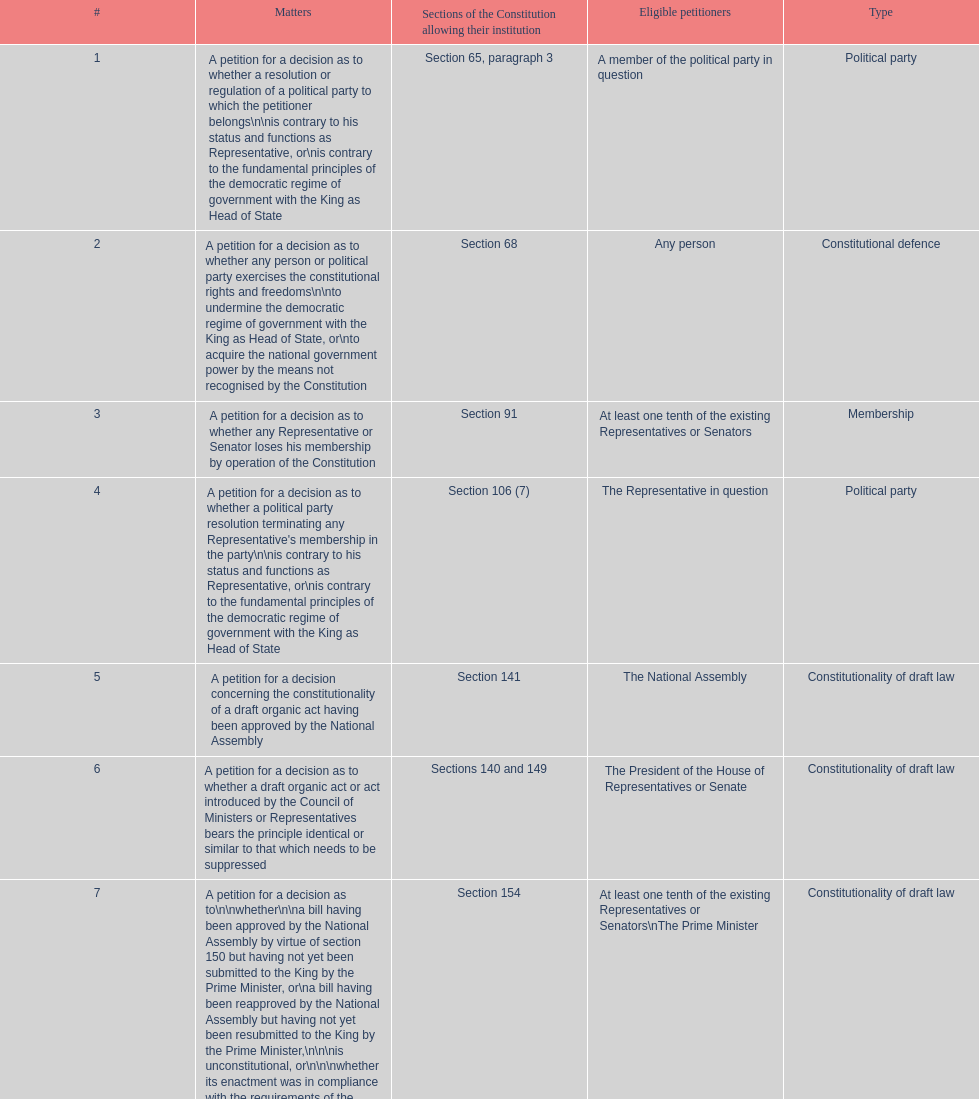Could you help me parse every detail presented in this table? {'header': ['#', 'Matters', 'Sections of the Constitution allowing their institution', 'Eligible petitioners', 'Type'], 'rows': [['1', 'A petition for a decision as to whether a resolution or regulation of a political party to which the petitioner belongs\\n\\nis contrary to his status and functions as Representative, or\\nis contrary to the fundamental principles of the democratic regime of government with the King as Head of State', 'Section 65, paragraph 3', 'A member of the political party in question', 'Political party'], ['2', 'A petition for a decision as to whether any person or political party exercises the constitutional rights and freedoms\\n\\nto undermine the democratic regime of government with the King as Head of State, or\\nto acquire the national government power by the means not recognised by the Constitution', 'Section 68', 'Any person', 'Constitutional defence'], ['3', 'A petition for a decision as to whether any Representative or Senator loses his membership by operation of the Constitution', 'Section 91', 'At least one tenth of the existing Representatives or Senators', 'Membership'], ['4', "A petition for a decision as to whether a political party resolution terminating any Representative's membership in the party\\n\\nis contrary to his status and functions as Representative, or\\nis contrary to the fundamental principles of the democratic regime of government with the King as Head of State", 'Section 106 (7)', 'The Representative in question', 'Political party'], ['5', 'A petition for a decision concerning the constitutionality of a draft organic act having been approved by the National Assembly', 'Section 141', 'The National Assembly', 'Constitutionality of draft law'], ['6', 'A petition for a decision as to whether a draft organic act or act introduced by the Council of Ministers or Representatives bears the principle identical or similar to that which needs to be suppressed', 'Sections 140 and 149', 'The President of the House of Representatives or Senate', 'Constitutionality of draft law'], ['7', 'A petition for a decision as to\\n\\nwhether\\n\\na bill having been approved by the National Assembly by virtue of section 150 but having not yet been submitted to the King by the Prime Minister, or\\na bill having been reapproved by the National Assembly but having not yet been resubmitted to the King by the Prime Minister,\\n\\n\\nis unconstitutional, or\\n\\n\\nwhether its enactment was in compliance with the requirements of the Constitution', 'Section 154', 'At least one tenth of the existing Representatives or Senators\\nThe Prime Minister', 'Constitutionality of draft law'], ['8', 'A petition for a decision as to\\n\\nwhether the draft rules of order of the House of Representatives, the draft rules of order of the Senate, or the draft rules of order of the National Assembly, which have been approved by the House of Representatives, Senate or National Assembly but have not yet been published in the Government Gazette, are unconstitutional, or\\nwhether their enactment was in compliance with the requirements of the Constitution', 'Section 155', 'At least one tenth of the existing Representatives or Senators\\nThe Prime Minister', 'Constitutionality of draft law'], ['9', 'A petition for a decision as to whether any motion, motion amendment or action introduced during the House of Representatives, Senate or committee proceedings for consideration of a draft bill on annual expenditure budget, additional expenditure budget or expenditure budget transfer, would allow a Representative, Senator or committee member to directly or indirectly be involved in the disbursement of such budget', 'Section 168, paragraph 7', 'At least one tenth of the existing Representatives or Senators', 'Others'], ['10', 'A petition for a decision as to whether any Minister individually loses his ministership', 'Section 182', 'At least one tenth of the existing Representatives or Senators\\nThe Election Commission', 'Membership'], ['11', 'A petition for a decision as to whether an emergency decree is enacted against section 184, paragraph 1 or 2, of the Constitution', 'Section 185', 'At least one fifth of the existing Representatives or Senators', 'Constitutionality of law'], ['12', 'A petition for a decision as to whether any "written agreement" to be concluded by the Executive Branch requires prior parliamentary approval because\\n\\nit contains a provision which would bring about a change in the Thai territory or the extraterritorial areas over which Thailand is competent to exercise sovereignty or jurisdiction by virtue of a written agreement or international law,\\nits execution requires the enactment of an act,\\nit would extensively affect national economic or social security, or\\nit would considerably bind national trade, investment or budget', 'Section 190', 'At least one tenth of the existing Representatives or Senators', 'Authority'], ['13', 'A petition for a decision as to whether a legal provision to be applied to any case by a court of justice, administrative court or military court is unconstitutional', 'Section 211', 'A party to such case', 'Constitutionality of law'], ['14', 'A petition for a decision as to the constitutionality of a legal provision', 'Section 212', 'Any person whose constitutionally recognised right or freedom has been violated', 'Constitutionality of law'], ['15', 'A petition for a decision as to a conflict of authority between the National Assembly, the Council of Ministers, or two or more constitutional organs other than the courts of justice, administrative courts or military courts', 'Section 214', 'The President of the National Assembly\\nThe Prime Minister\\nThe organs in question', 'Authority'], ['16', 'A petition for a decision as to whether any Election Commissioner lacks a qualification, is attacked by a disqualification or has committed a prohibited act', 'Section 233', 'At least one tenth of the existing Representatives or Senators', 'Membership'], ['17', 'A petition for\\n\\ndissolution of a political party deemed to have attempted to acquire the national government power by the means not recognised by the Constitution, and\\ndisfranchisement of its leader and executive members', 'Section 237 in conjunction with section 68', 'Any person', 'Political party'], ['18', 'A petition for a decision as to the constitutionality of any legal provision', 'Section 245 (1)', 'Ombudsmen', 'Constitutionality of law'], ['19', 'A petition for a decision as to the constitutionality of any legal provision on grounds of human rights', 'Section 257, paragraph 1 (2)', 'The National Human Rights Commission', 'Constitutionality of law'], ['20', 'Other matters permitted by legal provisions', '', '', 'Others']]} Any person can petition matters 2 and 17. true or false? True. 